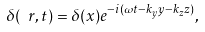<formula> <loc_0><loc_0><loc_500><loc_500>\delta ( \ r , t ) = \delta ( x ) e ^ { - i ( \omega t - k _ { y } y - k _ { z } z ) } ,</formula> 